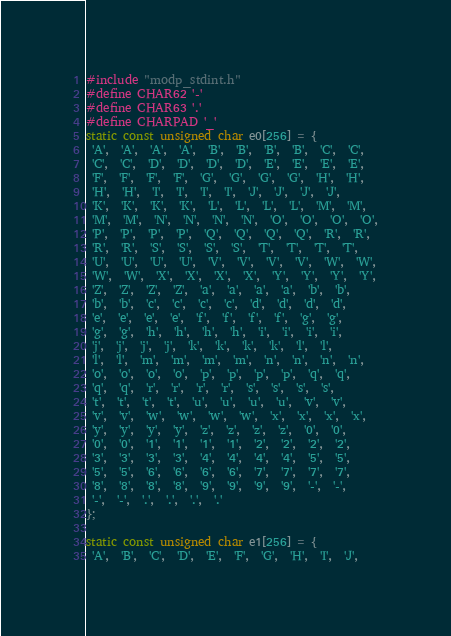<code> <loc_0><loc_0><loc_500><loc_500><_C_>#include "modp_stdint.h"
#define CHAR62 '-'
#define CHAR63 '.'
#define CHARPAD '_'
static const unsigned char e0[256] = {
 'A',  'A',  'A',  'A',  'B',  'B',  'B',  'B',  'C',  'C',
 'C',  'C',  'D',  'D',  'D',  'D',  'E',  'E',  'E',  'E',
 'F',  'F',  'F',  'F',  'G',  'G',  'G',  'G',  'H',  'H',
 'H',  'H',  'I',  'I',  'I',  'I',  'J',  'J',  'J',  'J',
 'K',  'K',  'K',  'K',  'L',  'L',  'L',  'L',  'M',  'M',
 'M',  'M',  'N',  'N',  'N',  'N',  'O',  'O',  'O',  'O',
 'P',  'P',  'P',  'P',  'Q',  'Q',  'Q',  'Q',  'R',  'R',
 'R',  'R',  'S',  'S',  'S',  'S',  'T',  'T',  'T',  'T',
 'U',  'U',  'U',  'U',  'V',  'V',  'V',  'V',  'W',  'W',
 'W',  'W',  'X',  'X',  'X',  'X',  'Y',  'Y',  'Y',  'Y',
 'Z',  'Z',  'Z',  'Z',  'a',  'a',  'a',  'a',  'b',  'b',
 'b',  'b',  'c',  'c',  'c',  'c',  'd',  'd',  'd',  'd',
 'e',  'e',  'e',  'e',  'f',  'f',  'f',  'f',  'g',  'g',
 'g',  'g',  'h',  'h',  'h',  'h',  'i',  'i',  'i',  'i',
 'j',  'j',  'j',  'j',  'k',  'k',  'k',  'k',  'l',  'l',
 'l',  'l',  'm',  'm',  'm',  'm',  'n',  'n',  'n',  'n',
 'o',  'o',  'o',  'o',  'p',  'p',  'p',  'p',  'q',  'q',
 'q',  'q',  'r',  'r',  'r',  'r',  's',  's',  's',  's',
 't',  't',  't',  't',  'u',  'u',  'u',  'u',  'v',  'v',
 'v',  'v',  'w',  'w',  'w',  'w',  'x',  'x',  'x',  'x',
 'y',  'y',  'y',  'y',  'z',  'z',  'z',  'z',  '0',  '0',
 '0',  '0',  '1',  '1',  '1',  '1',  '2',  '2',  '2',  '2',
 '3',  '3',  '3',  '3',  '4',  '4',  '4',  '4',  '5',  '5',
 '5',  '5',  '6',  '6',  '6',  '6',  '7',  '7',  '7',  '7',
 '8',  '8',  '8',  '8',  '9',  '9',  '9',  '9',  '-',  '-',
 '-',  '-',  '.',  '.',  '.',  '.'
};

static const unsigned char e1[256] = {
 'A',  'B',  'C',  'D',  'E',  'F',  'G',  'H',  'I',  'J',</code> 